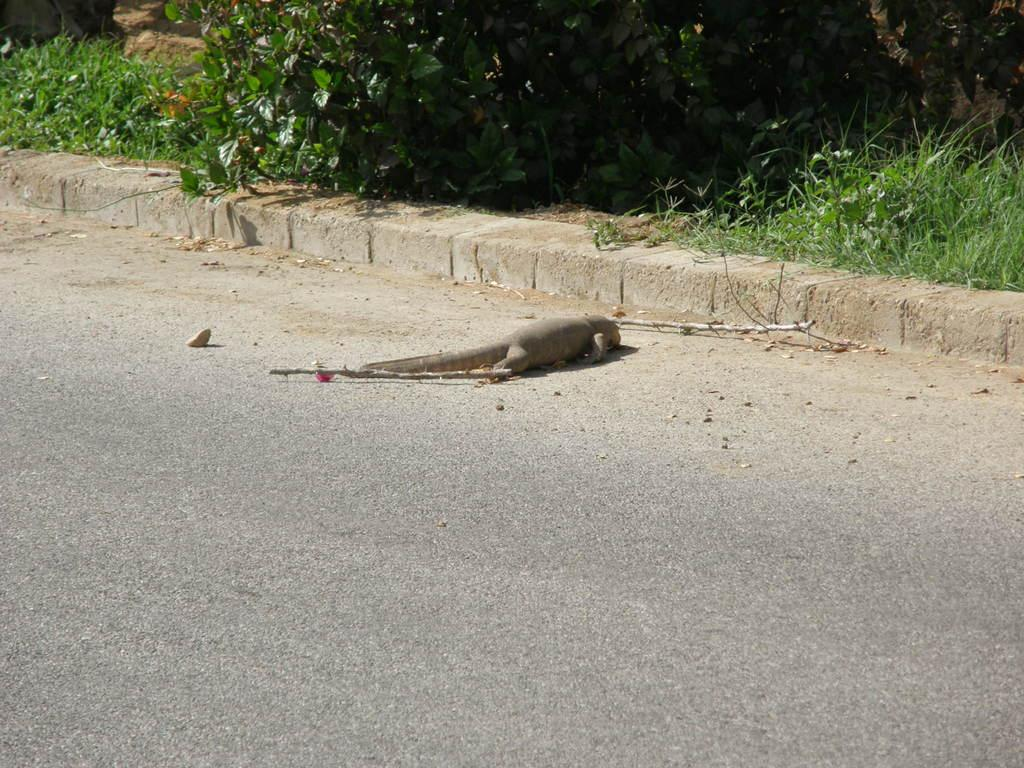What is the main subject in the center of the image? There is an animal lying in the center of the image. What can be seen on the road in the image? There are stocks on the road. What type of natural environment is visible in the background of the image? There are trees and grass in the background of the image. What is the weight of the hand holding the animal in the image? There is no hand holding the animal in the image; the animal is lying on its own. 